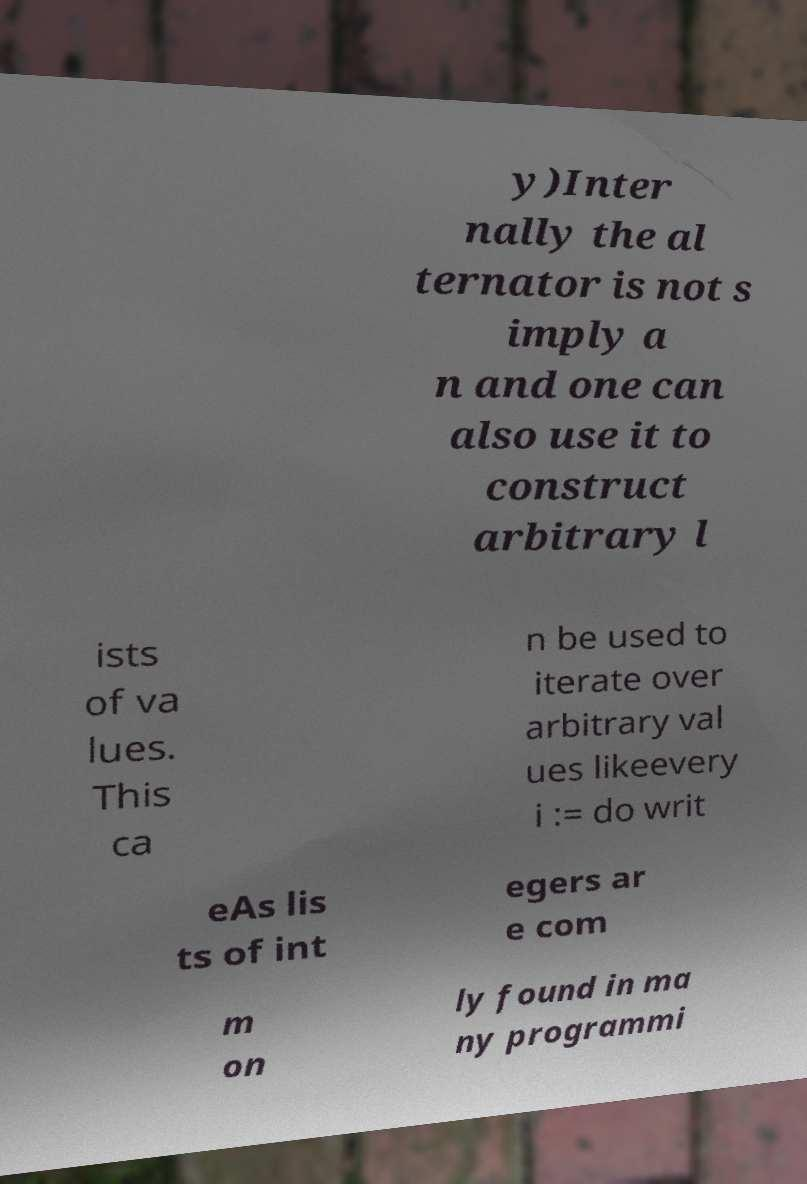Could you assist in decoding the text presented in this image and type it out clearly? y)Inter nally the al ternator is not s imply a n and one can also use it to construct arbitrary l ists of va lues. This ca n be used to iterate over arbitrary val ues likeevery i := do writ eAs lis ts of int egers ar e com m on ly found in ma ny programmi 